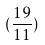<formula> <loc_0><loc_0><loc_500><loc_500>( \frac { 1 9 } { 1 1 } )</formula> 